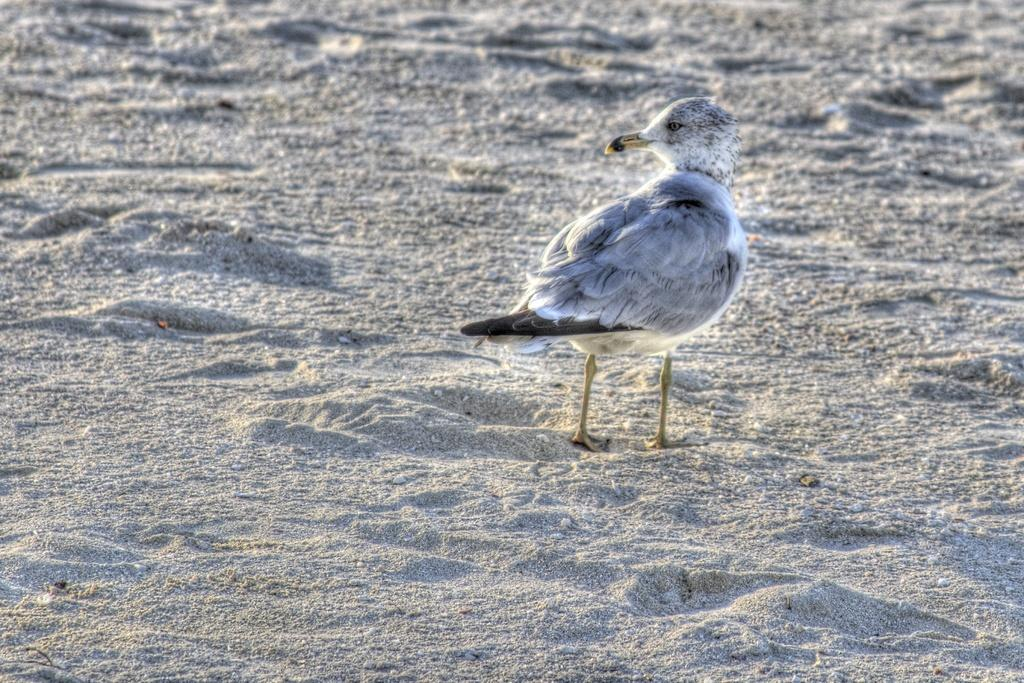What type of animal can be seen in the image? There is a bird in the image. Can you describe the color pattern of the bird? The bird is white and black in color. What type of terrain is visible in the image? There is sand visible in the image. How many snails are participating in the bird's voyage in the image? There are no snails or voyages mentioned in the image; it features a bird and sand. What hobbies does the bird have, as depicted in the image? The image does not provide information about the bird's hobbies; it only shows the bird and its color pattern. 